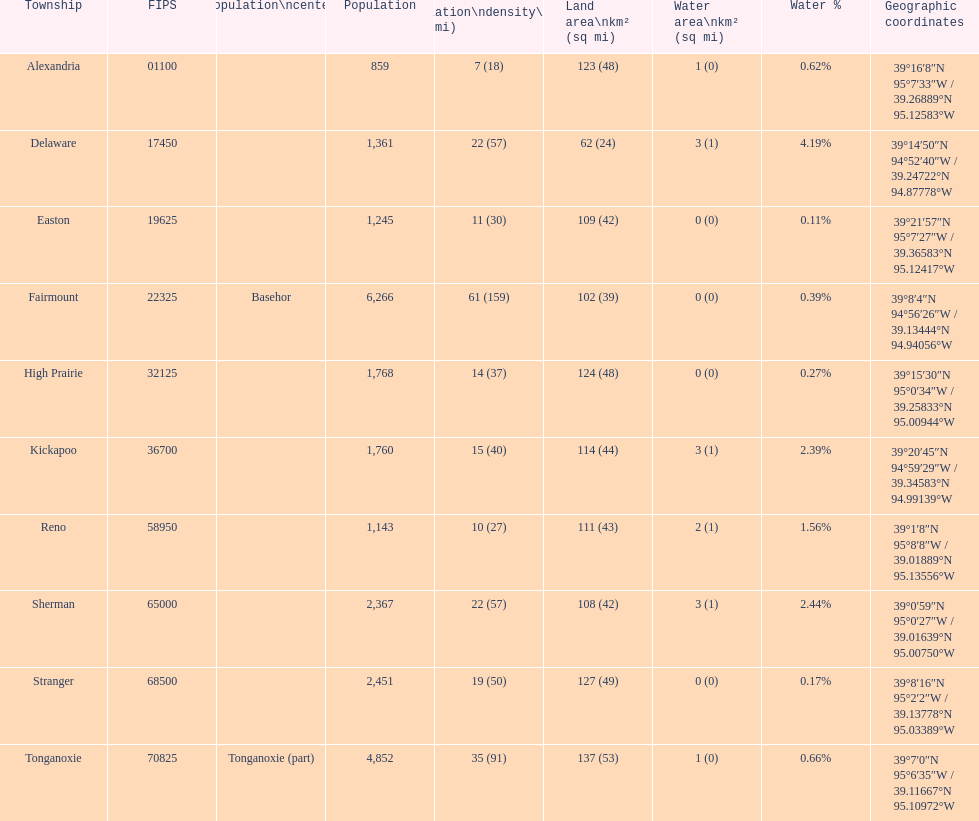What is the difference of population in easton and reno? 102. 